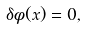<formula> <loc_0><loc_0><loc_500><loc_500>\delta \phi ( x ) = 0 ,</formula> 